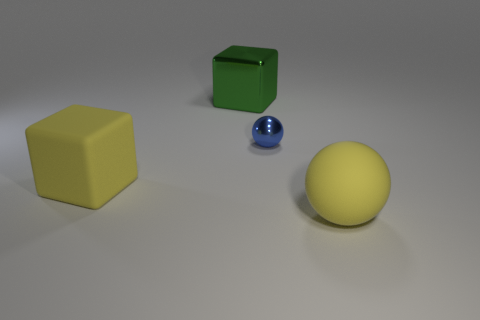There is a large yellow block; are there any large green blocks left of it?
Provide a succinct answer. No. There is a rubber ball that is the same size as the rubber cube; what is its color?
Offer a terse response. Yellow. How many things are objects that are in front of the green block or yellow matte objects?
Offer a terse response. 3. There is a object that is both in front of the blue metallic sphere and behind the matte ball; what is its size?
Give a very brief answer. Large. What is the size of the rubber object that is the same color as the large rubber sphere?
Your answer should be compact. Large. How many other objects are the same size as the green shiny cube?
Make the answer very short. 2. What color is the sphere that is in front of the cube in front of the thing behind the tiny blue shiny ball?
Offer a very short reply. Yellow. What is the shape of the large thing that is on the right side of the large yellow cube and in front of the large green thing?
Your response must be concise. Sphere. How many other objects are there of the same shape as the tiny blue thing?
Ensure brevity in your answer.  1. The big yellow object on the left side of the large matte sphere to the right of the yellow thing left of the metallic cube is what shape?
Give a very brief answer. Cube. 